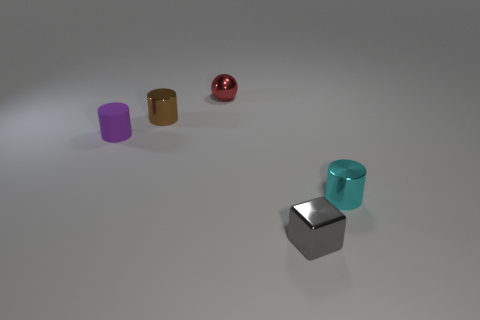What number of other things are there of the same shape as the gray metal object?
Offer a terse response. 0. What is the material of the thing that is in front of the cylinder to the right of the red metal sphere?
Your answer should be very brief. Metal. Are there any small cyan metallic cylinders to the left of the cyan shiny thing?
Ensure brevity in your answer.  No. There is a brown shiny cylinder; does it have the same size as the metal thing that is in front of the cyan thing?
Provide a short and direct response. Yes. What is the size of the purple matte thing that is the same shape as the small cyan metallic thing?
Make the answer very short. Small. Is there any other thing that has the same material as the purple object?
Your response must be concise. No. There is a shiny thing that is behind the tiny brown cylinder; does it have the same size as the cylinder that is on the right side of the small red ball?
Your response must be concise. Yes. What number of tiny things are green things or matte cylinders?
Your response must be concise. 1. How many objects are behind the gray shiny cube and on the right side of the red ball?
Offer a terse response. 1. Does the purple thing have the same material as the cylinder behind the small purple matte cylinder?
Keep it short and to the point. No. 